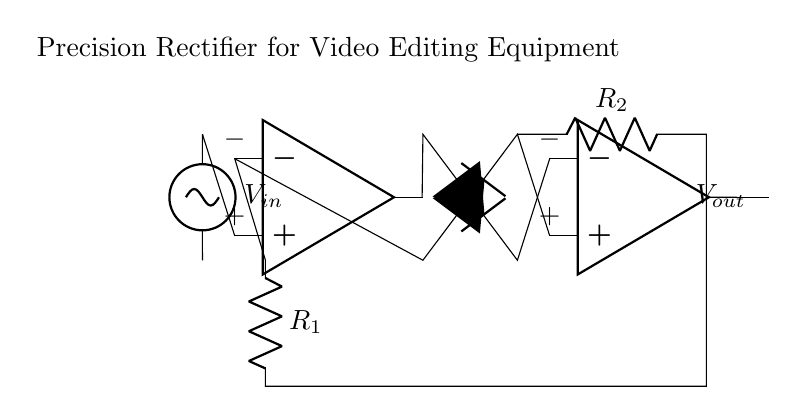What are the main components of this circuit? The circuit primarily consists of two operational amplifiers, two diodes, and two resistors. Observing the diagram, you can see distinct symbols for each component.
Answer: operational amplifiers, diodes, resistors What type of rectifier does this circuit represent? This is a precision rectifier, as indicated by the configuration of the operational amplifiers and diodes that allow for accurate rectification of input signals without significant voltage drop.
Answer: precision rectifier What is the purpose of the resistors in this circuit? The resistors, labeled R1 and R2, are essential for setting the gain of the operational amplifiers and establishing the thresholds for signal processing. Their values help determine how the input voltage gets amplified or modified before rectification.
Answer: gain setting What is the expected output of this precision rectifier? The output, labeled as Vout, is expected to be an accurate representation of the input signal, rectified to only show the positive portion thanks to the configuration of the diodes and operational amplifiers.
Answer: accurate positive signal Why are operational amplifiers used in this rectifier circuit? Operational amplifiers are used to ensure that the rectification occurs with high precision and allows for low voltage drops. They amplify the input signal before it interacts with the diodes, which helps maintain signal integrity for processing, especially important in video editing.
Answer: high precision, low voltage drop How does the circuit handle negative input voltages? The precision rectifier allows negative input voltages to be inverted and not passed to the output at all, effectively clipping them off and ensuring that only positive portions contribute to Vout, thus achieving rectification.
Answer: clips negative voltages 